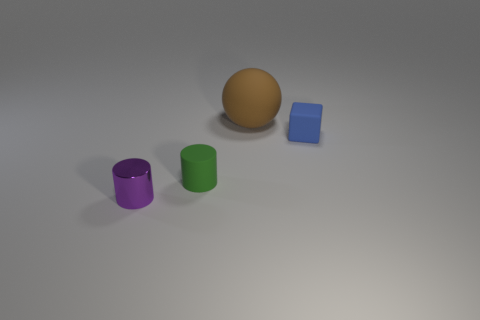Add 4 blue rubber objects. How many objects exist? 8 Subtract 1 cylinders. How many cylinders are left? 1 Subtract all purple metal things. Subtract all cylinders. How many objects are left? 1 Add 1 purple shiny things. How many purple shiny things are left? 2 Add 1 tiny green things. How many tiny green things exist? 2 Subtract 0 brown cylinders. How many objects are left? 4 Subtract all cyan balls. Subtract all green cylinders. How many balls are left? 1 